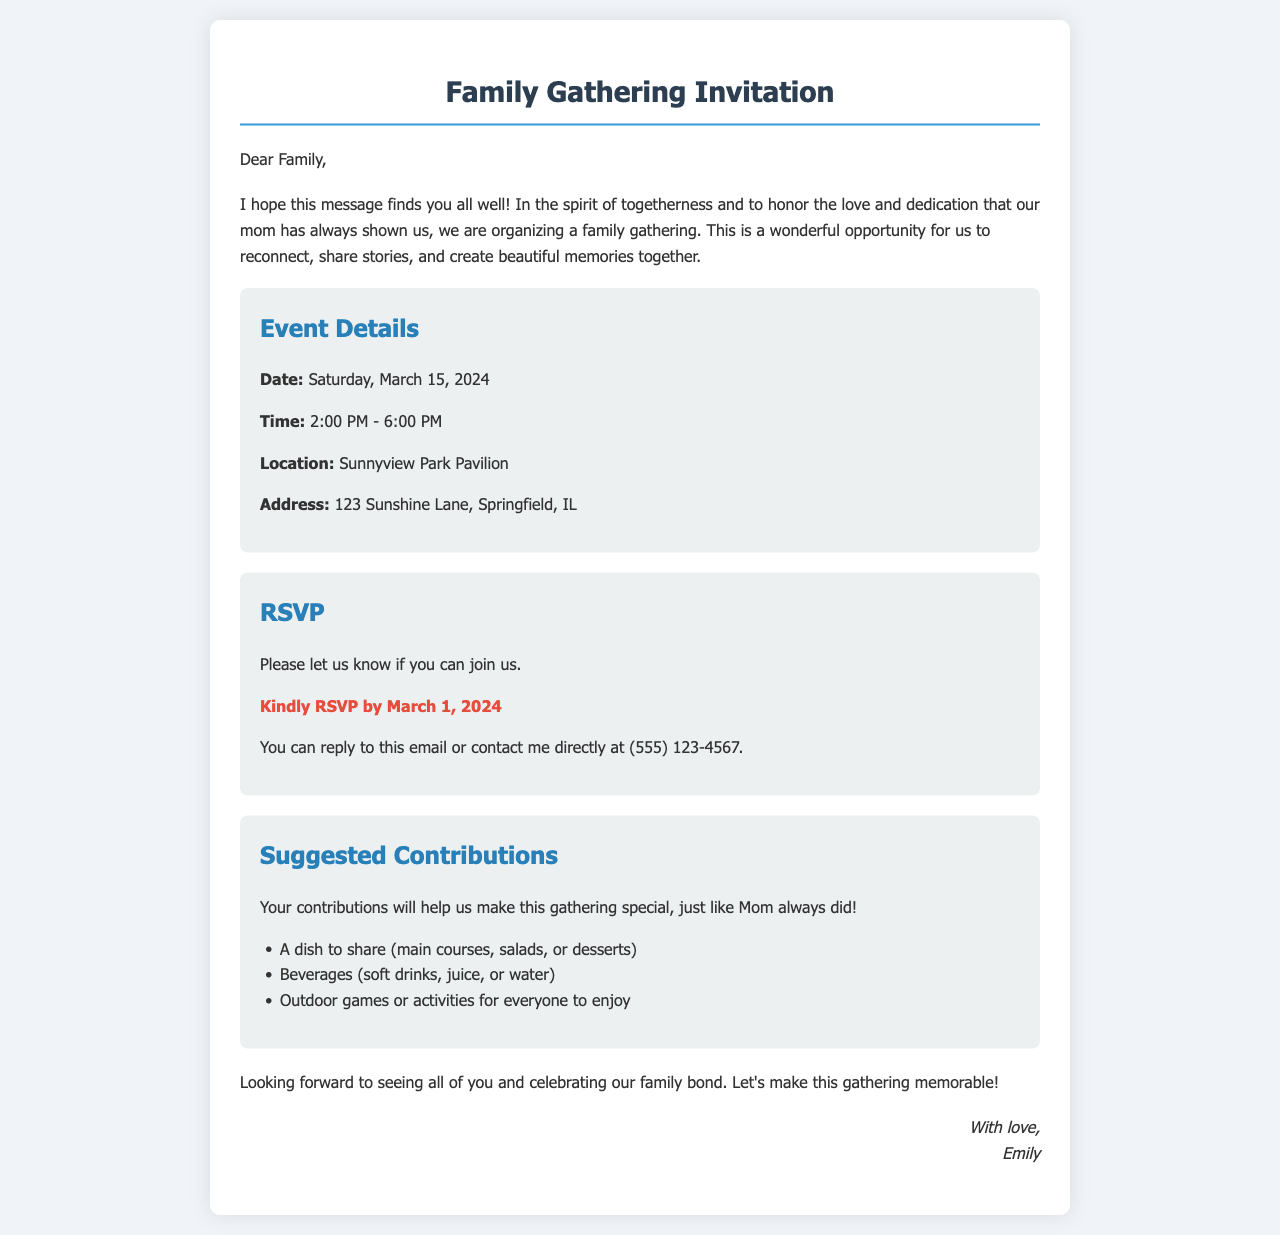What is the date of the gathering? The date of the gathering is clearly stated in the details section of the document.
Answer: Saturday, March 15, 2024 What time does the gathering start? The starting time of the gathering is included in the event details section.
Answer: 2:00 PM Where is the gathering being held? The location of the gathering is specified in the details section along with the address.
Answer: Sunnyview Park Pavilion What is the RSVP deadline? The RSVP deadline is highlighted in the RSVP section of the invitation.
Answer: March 1, 2024 What contributions are suggested for the gathering? The suggested contributions are listed in a bullet point format in the contributions section.
Answer: A dish to share, Beverages, Outdoor games or activities Why is the family gathering being organized? The reason for organizing the gathering is mentioned in the introduction, emphasizing family togetherness.
Answer: To honor the love and dedication that our mom has always shown us How can family members RSVP? The method for RSVPing is outlined in the RSVP section of the document.
Answer: Reply to this email or contact me directly at (555) 123-4567 What is the purpose of the gathering according to the document? The purpose of the gathering is provided in the introduction, which sets the tone for the event.
Answer: To reconnect, share stories, and create beautiful memories together 